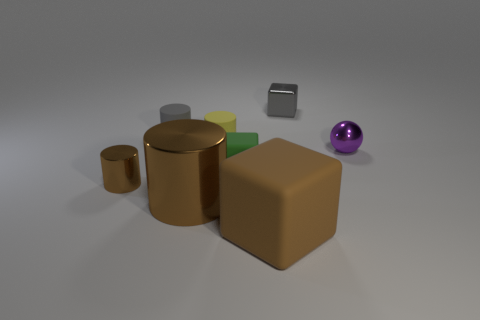Do the large block and the big metal object have the same color?
Provide a succinct answer. Yes. How many other objects are the same shape as the tiny green matte thing?
Provide a succinct answer. 2. There is a tiny cylinder to the left of the gray matte thing; is its color the same as the small block behind the purple ball?
Provide a short and direct response. No. How many big things are cyan metallic spheres or green rubber objects?
Your answer should be compact. 0. There is another rubber thing that is the same shape as the big brown rubber object; what is its size?
Provide a short and direct response. Small. There is a small gray thing in front of the cube that is behind the yellow matte thing; what is it made of?
Your answer should be compact. Rubber. What number of matte things are gray cubes or small brown things?
Provide a short and direct response. 0. What color is the other large metallic thing that is the same shape as the yellow thing?
Your answer should be very brief. Brown. What number of big metallic cylinders have the same color as the big shiny object?
Give a very brief answer. 0. There is a matte object that is right of the tiny green matte object; is there a small green rubber object in front of it?
Ensure brevity in your answer.  No. 